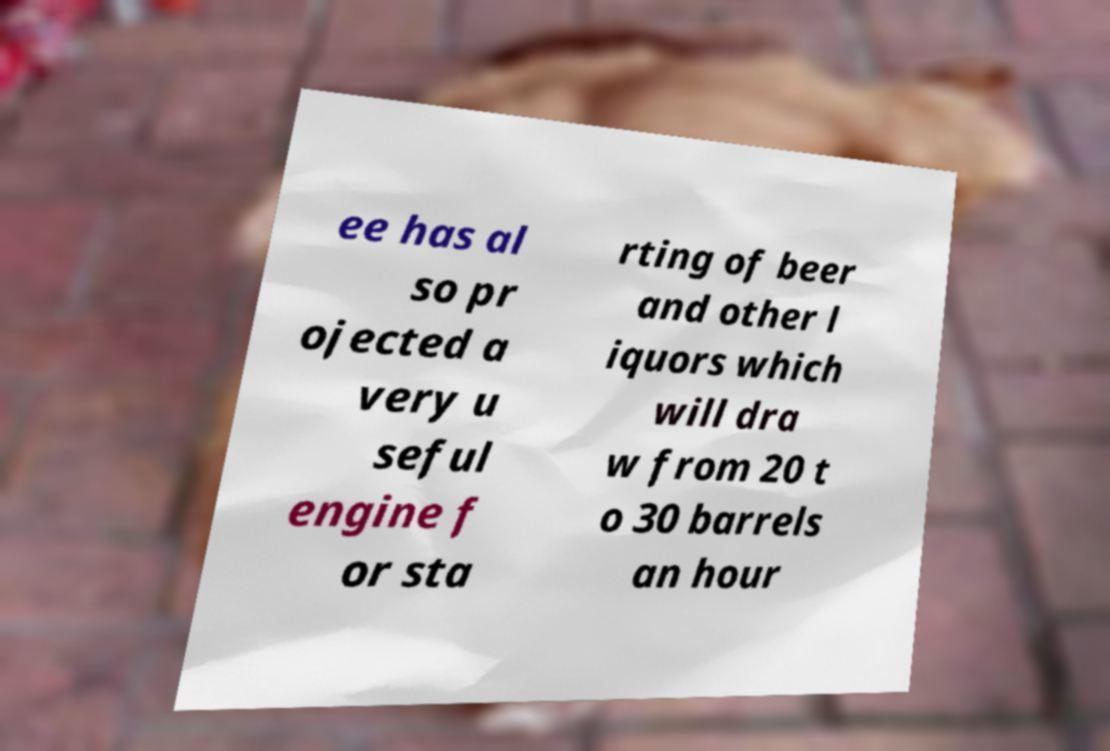Please read and relay the text visible in this image. What does it say? ee has al so pr ojected a very u seful engine f or sta rting of beer and other l iquors which will dra w from 20 t o 30 barrels an hour 